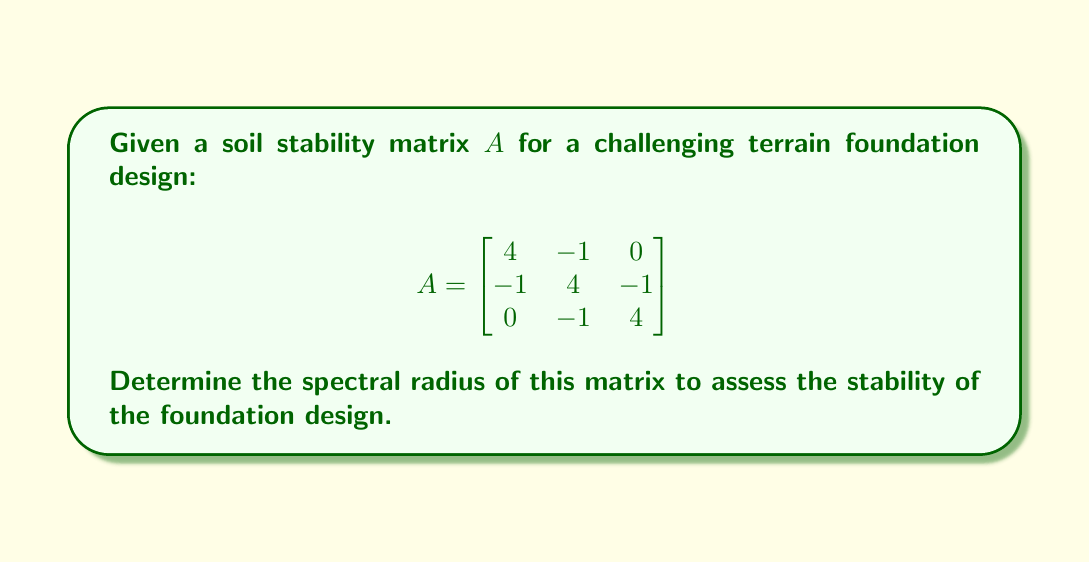Could you help me with this problem? To determine the spectral radius of matrix $A$, we follow these steps:

1) First, we need to find the eigenvalues of matrix $A$. The characteristic equation is:

   $\det(A - \lambda I) = 0$

2) Expanding the determinant:

   $$\begin{vmatrix}
   4-\lambda & -1 & 0 \\
   -1 & 4-\lambda & -1 \\
   0 & -1 & 4-\lambda
   \end{vmatrix} = 0$$

3) This gives us the equation:

   $(4-\lambda)[(4-\lambda)^2 - 1] - (-1)[-1] = 0$

4) Simplifying:

   $(4-\lambda)[(4-\lambda)^2 - 1] + 1 = 0$
   $(4-\lambda)(16-8\lambda+\lambda^2 - 1) + 1 = 0$
   $(4-\lambda)(15-8\lambda+\lambda^2) + 1 = 0$
   $60-32\lambda+4\lambda^2-15\lambda+8\lambda^2-\lambda^3 + 1 = 0$
   $-\lambda^3+12\lambda^2-47\lambda+61 = 0$

5) This cubic equation can be factored as:

   $-(\lambda-5)(\lambda-3)(\lambda-4) = 0$

6) Therefore, the eigenvalues are $\lambda_1 = 5$, $\lambda_2 = 3$, and $\lambda_3 = 4$

7) The spectral radius is defined as the maximum absolute value of the eigenvalues:

   $\rho(A) = \max\{|\lambda_1|, |\lambda_2|, |\lambda_3|\} = \max\{5, 3, 4\} = 5$
Answer: $\rho(A) = 5$ 